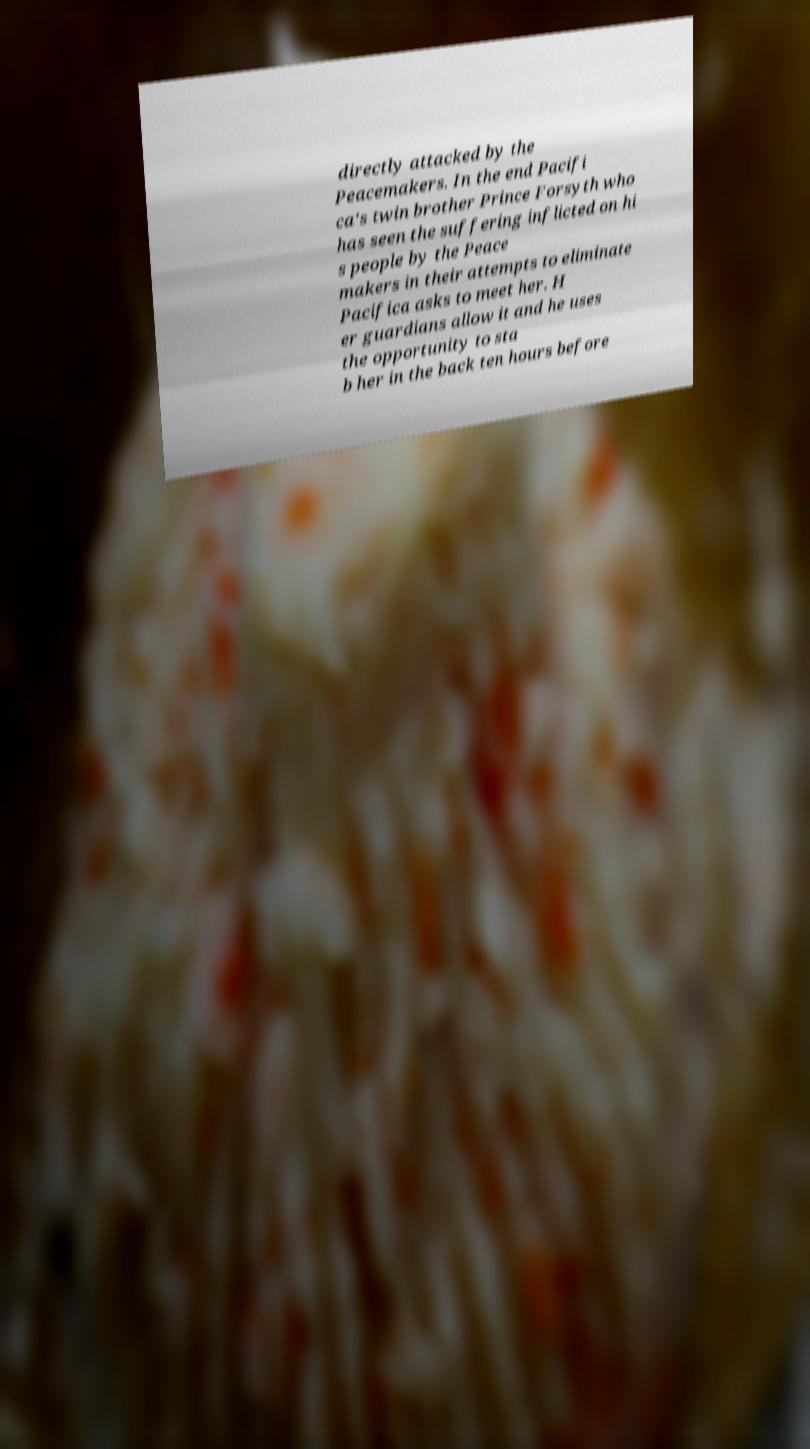I need the written content from this picture converted into text. Can you do that? directly attacked by the Peacemakers. In the end Pacifi ca's twin brother Prince Forsyth who has seen the suffering inflicted on hi s people by the Peace makers in their attempts to eliminate Pacifica asks to meet her. H er guardians allow it and he uses the opportunity to sta b her in the back ten hours before 